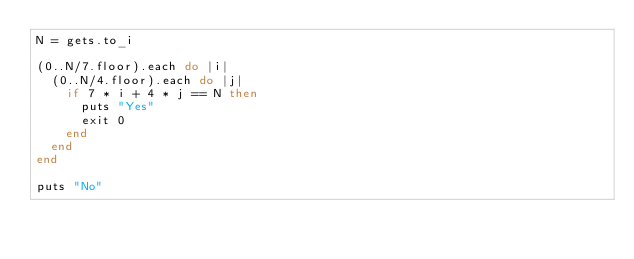Convert code to text. <code><loc_0><loc_0><loc_500><loc_500><_Ruby_>N = gets.to_i

(0..N/7.floor).each do |i|
  (0..N/4.floor).each do |j|
    if 7 * i + 4 * j == N then
      puts "Yes"
      exit 0
    end
  end
end

puts "No"</code> 